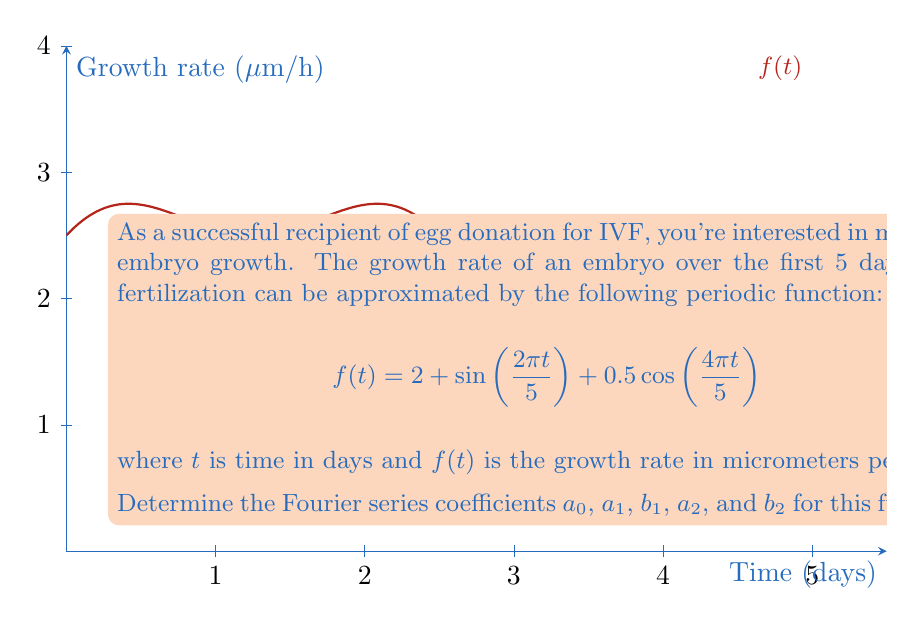Could you help me with this problem? Let's approach this step-by-step:

1) The general form of a Fourier series is:

   $$f(t) = \frac{a_0}{2} + \sum_{n=1}^{\infty} (a_n\cos(\frac{2\pi nt}{T}) + b_n\sin(\frac{2\pi nt}{T}))$$

   where $T$ is the period of the function.

2) In our case, $T = 5$ days, and we're given:

   $$f(t) = 2 + \sin(\frac{2\pi t}{5}) + 0.5\cos(\frac{4\pi t}{5})$$

3) Comparing this with the general form, we can identify:

   $\frac{a_0}{2} = 2$, so $a_0 = 4$

   $b_1 = 1$ (coefficient of $\sin(\frac{2\pi t}{5})$)

   $a_1 = 0$ (no $\cos(\frac{2\pi t}{5})$ term)

   $a_2 = 0.5$ (coefficient of $\cos(\frac{4\pi t}{5})$)

   $b_2 = 0$ (no $\sin(\frac{4\pi t}{5})$ term)

4) Therefore, the Fourier series coefficients are:

   $a_0 = 4$
   $a_1 = 0$
   $b_1 = 1$
   $a_2 = 0.5$
   $b_2 = 0$
Answer: $a_0 = 4$, $a_1 = 0$, $b_1 = 1$, $a_2 = 0.5$, $b_2 = 0$ 